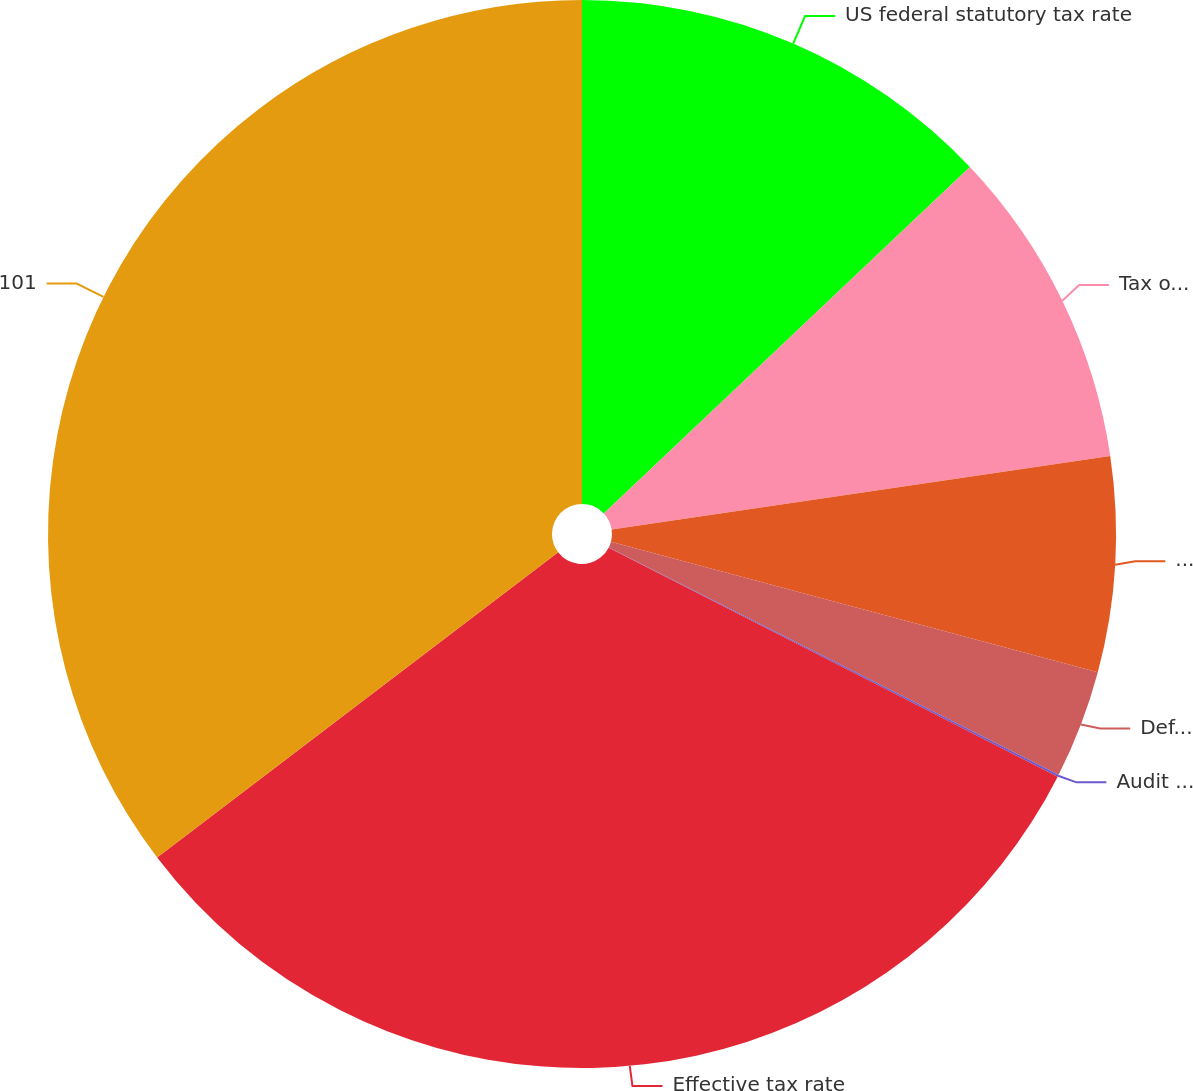<chart> <loc_0><loc_0><loc_500><loc_500><pie_chart><fcel>US federal statutory tax rate<fcel>Tax on income of foreign<fcel>US state and local income<fcel>Deferred tax effect of<fcel>Audit settlements and changes<fcel>Effective tax rate<fcel>101<nl><fcel>12.94%<fcel>9.72%<fcel>6.5%<fcel>3.28%<fcel>0.06%<fcel>32.13%<fcel>35.35%<nl></chart> 